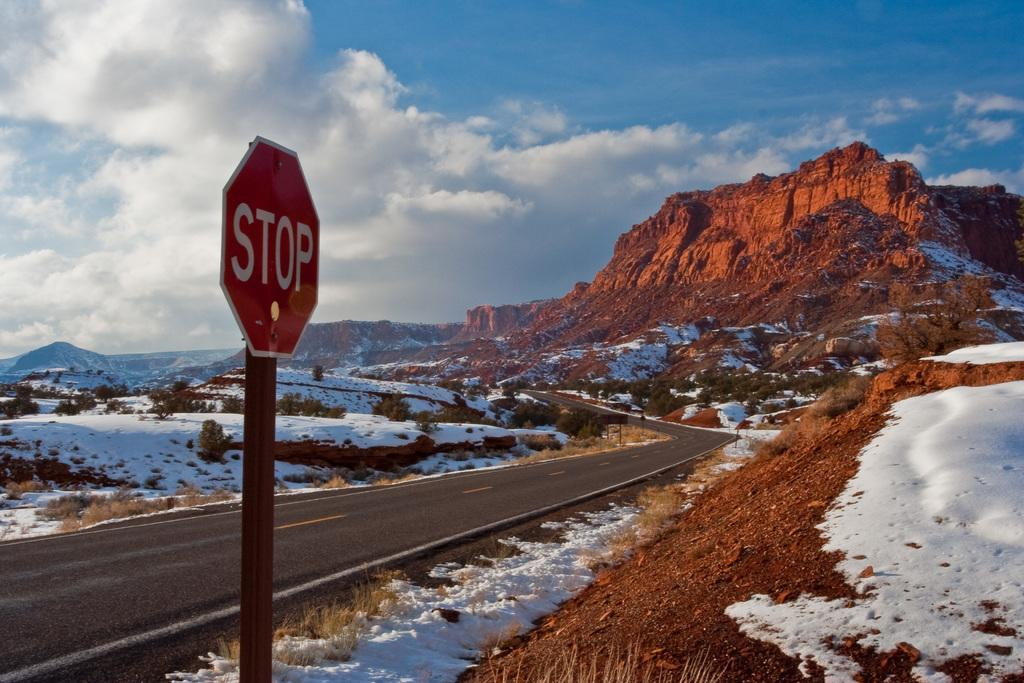Provide a one-sentence caption for the provided image. Stop sign on the side of a road that is covered with snow. 